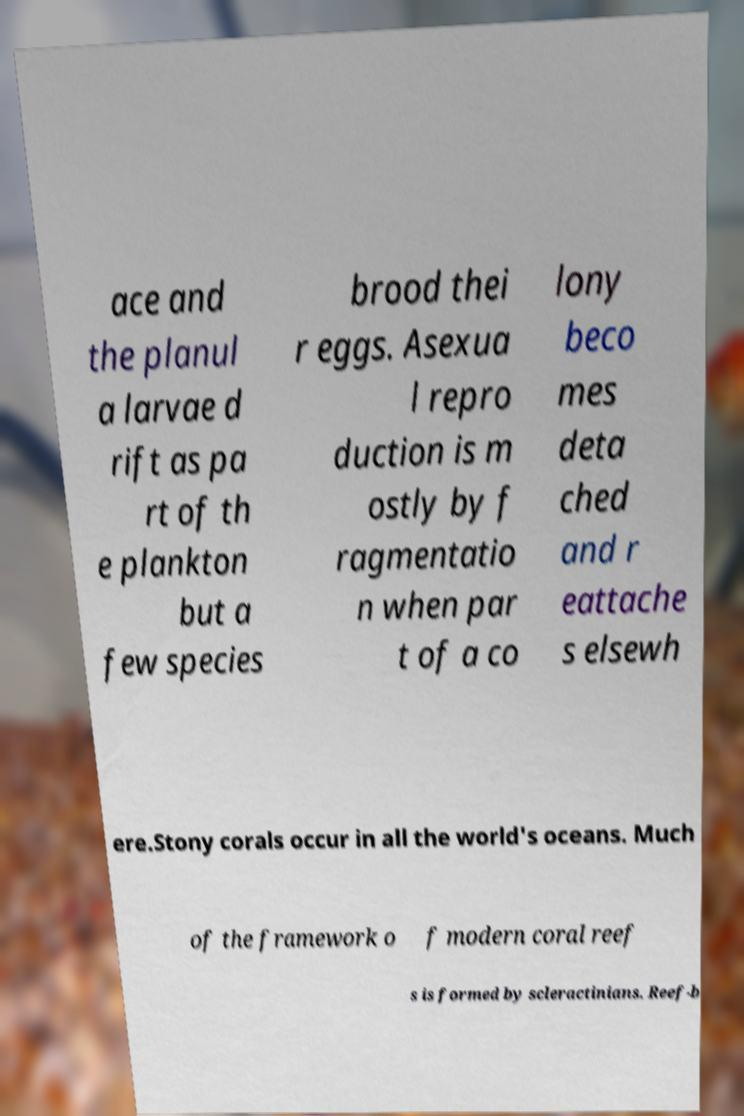Please identify and transcribe the text found in this image. ace and the planul a larvae d rift as pa rt of th e plankton but a few species brood thei r eggs. Asexua l repro duction is m ostly by f ragmentatio n when par t of a co lony beco mes deta ched and r eattache s elsewh ere.Stony corals occur in all the world's oceans. Much of the framework o f modern coral reef s is formed by scleractinians. Reef-b 